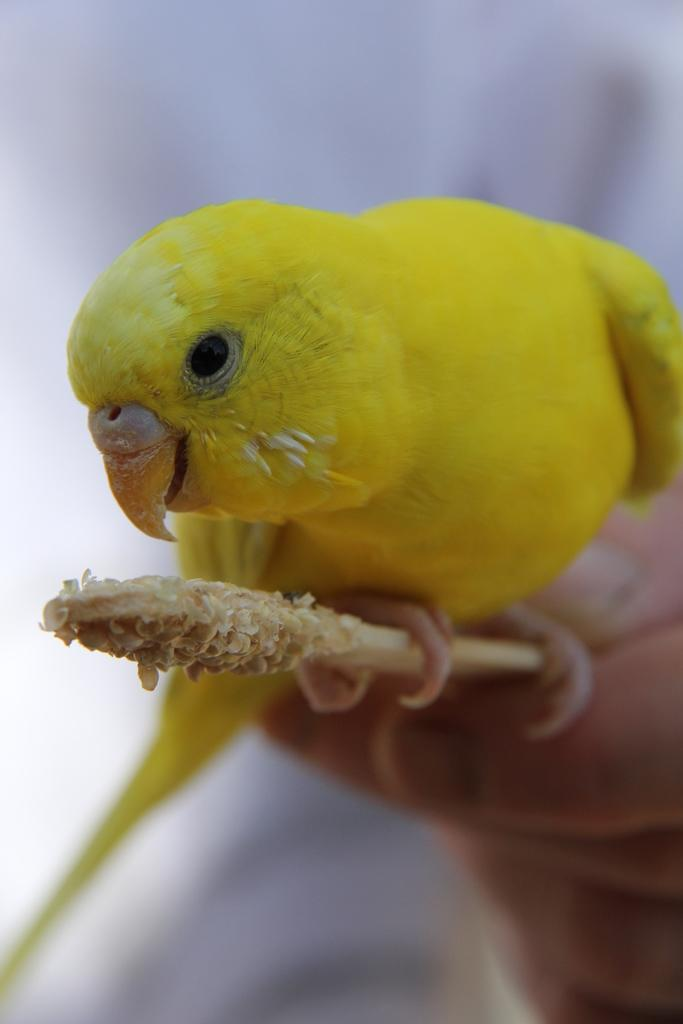What is the main subject in the center of the image? There is a human hand in the center of the image. What is the hand holding? The hand is holding a stick. What is on the stick? There is a bird on the stick. What color is the bird? The bird is yellow in color. What type of noise is the bird making in the image? There is no indication of any noise in the image, as it only shows a hand holding a stick with a yellow bird on it. 